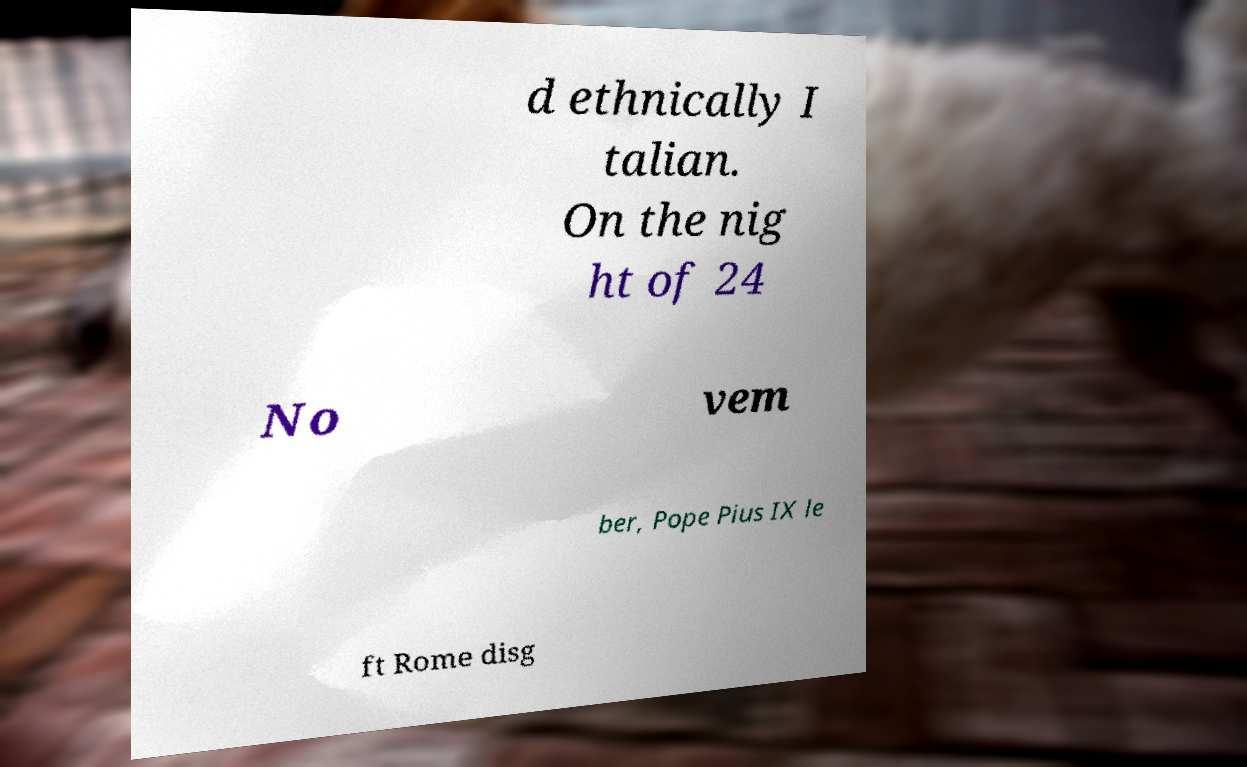Please identify and transcribe the text found in this image. d ethnically I talian. On the nig ht of 24 No vem ber, Pope Pius IX le ft Rome disg 